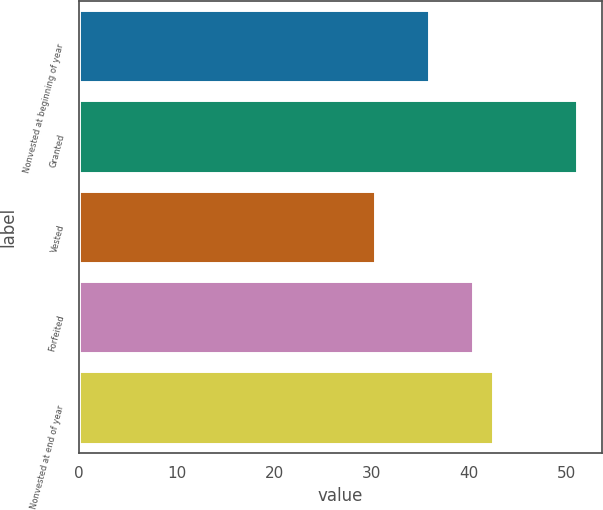<chart> <loc_0><loc_0><loc_500><loc_500><bar_chart><fcel>Nonvested at beginning of year<fcel>Granted<fcel>Vested<fcel>Forfeited<fcel>Nonvested at end of year<nl><fcel>35.94<fcel>51.1<fcel>30.38<fcel>40.41<fcel>42.48<nl></chart> 